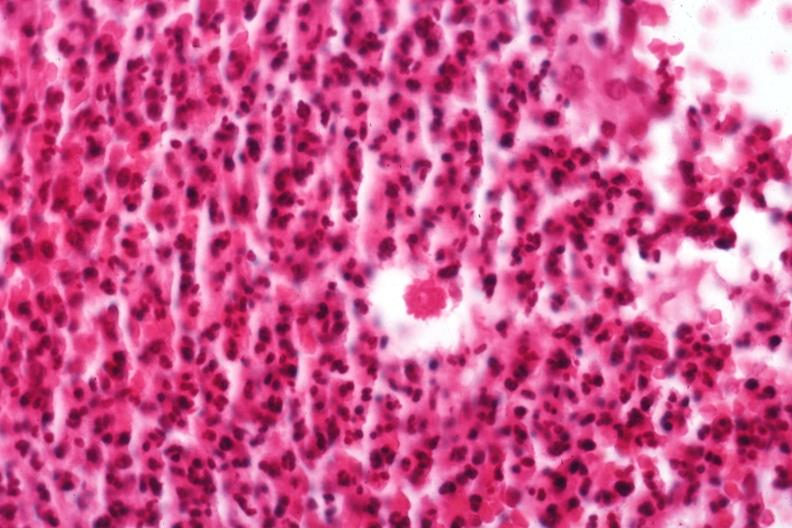what is present?
Answer the question using a single word or phrase. Sporotrichosis 